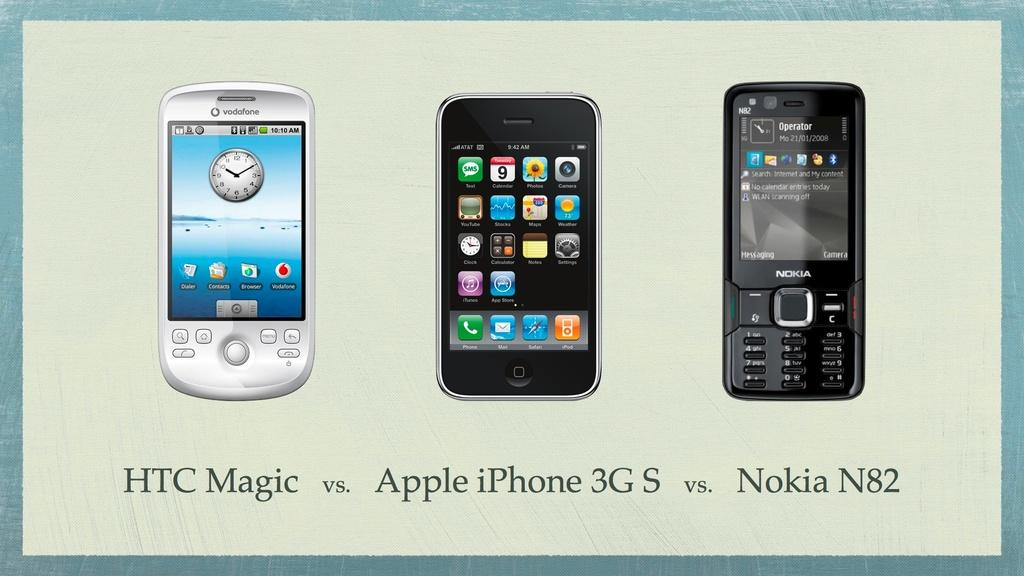<image>
Create a compact narrative representing the image presented. The cellphone on the left is a Nokia N82. 